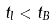<formula> <loc_0><loc_0><loc_500><loc_500>t _ { l } < t _ { B }</formula> 